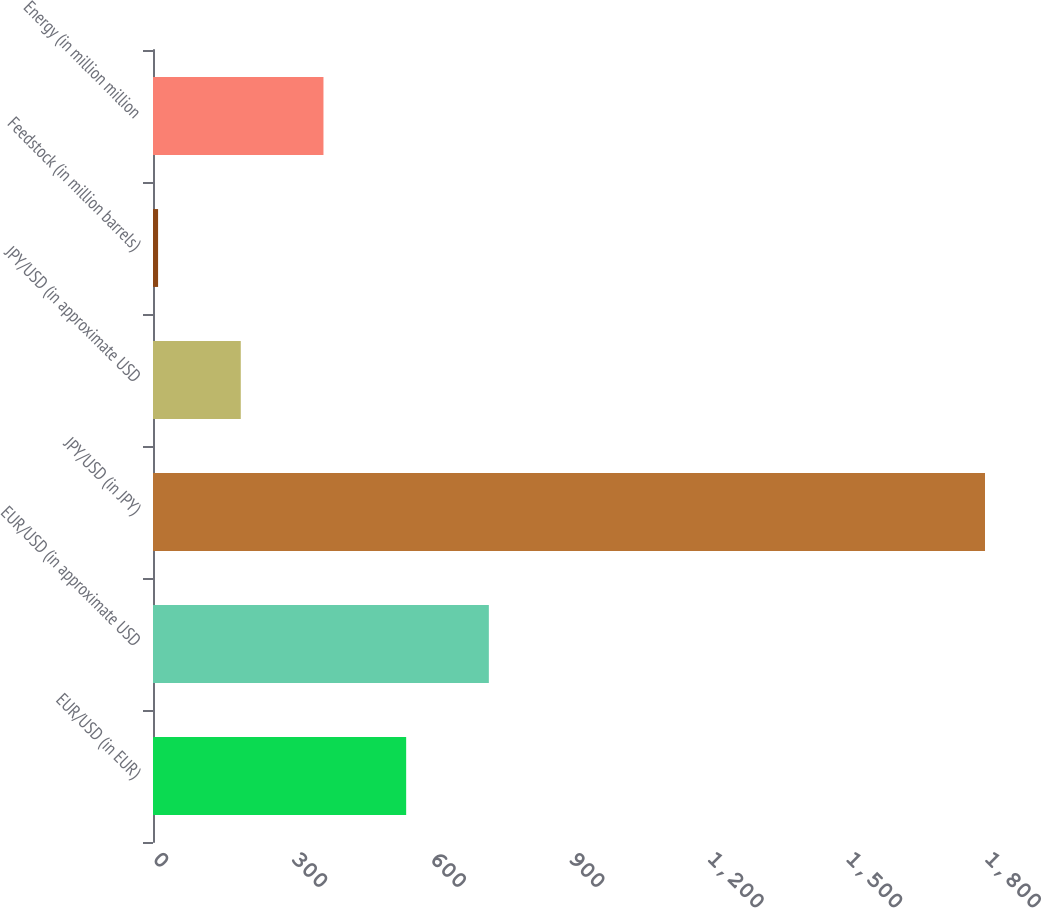Convert chart to OTSL. <chart><loc_0><loc_0><loc_500><loc_500><bar_chart><fcel>EUR/USD (in EUR)<fcel>EUR/USD (in approximate USD<fcel>JPY/USD (in JPY)<fcel>JPY/USD (in approximate USD<fcel>Feedstock (in million barrels)<fcel>Energy (in million million<nl><fcel>547.7<fcel>726.6<fcel>1800<fcel>189.9<fcel>11<fcel>368.8<nl></chart> 